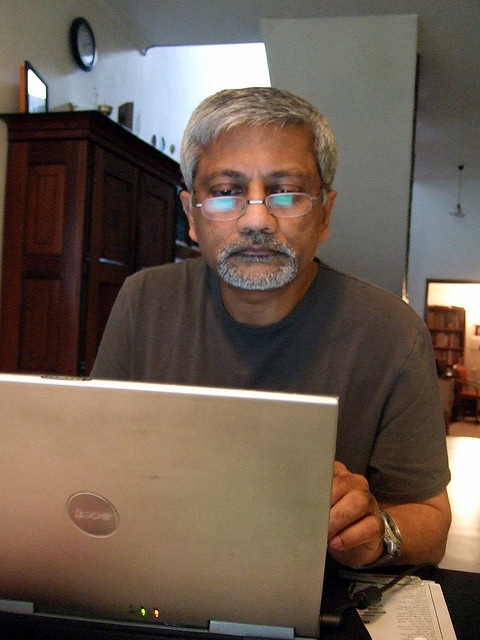Describe the objects in this image and their specific colors. I can see people in gray, black, and maroon tones, laptop in gray, tan, and black tones, clock in gray, black, and blue tones, book in gray, maroon, and brown tones, and book in gray, maroon, brown, and tan tones in this image. 